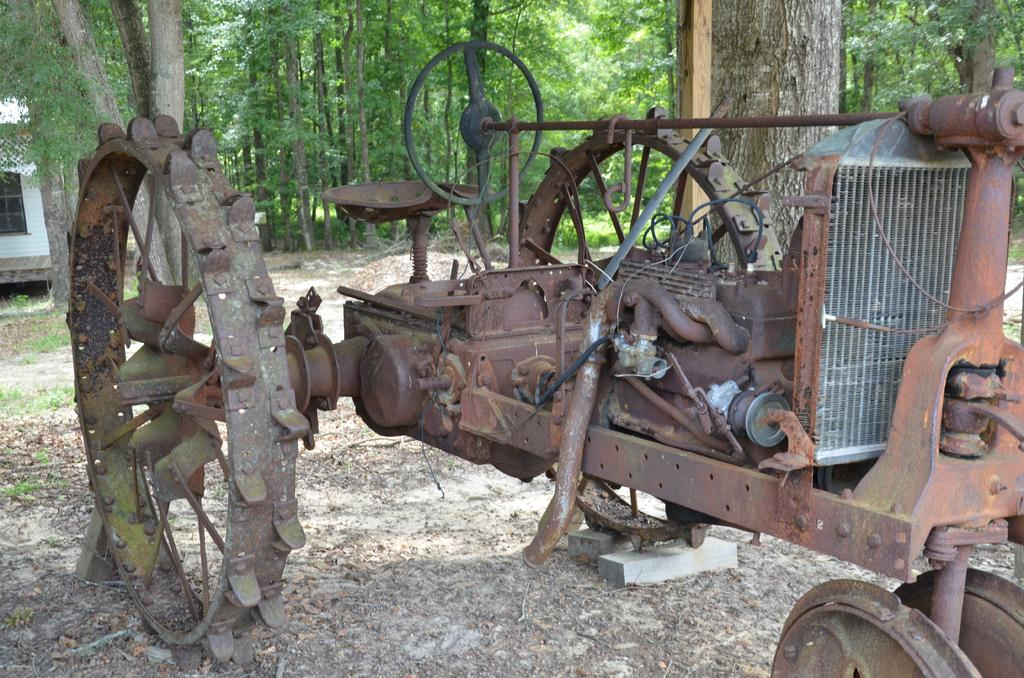What is the main subject in the foreground of the image? There is a vehicle in the foreground of the image. What can be seen on the left side of the image? A: There is a building on the left side of the image. What type of vegetation is visible in the image? There are trees and grass visible in the image. What is the terrain like at the bottom of the image? There is mud at the bottom of the image. Can you see any art pieces displayed on the building in the image? There is no mention of any art pieces displayed on the building in the image. 